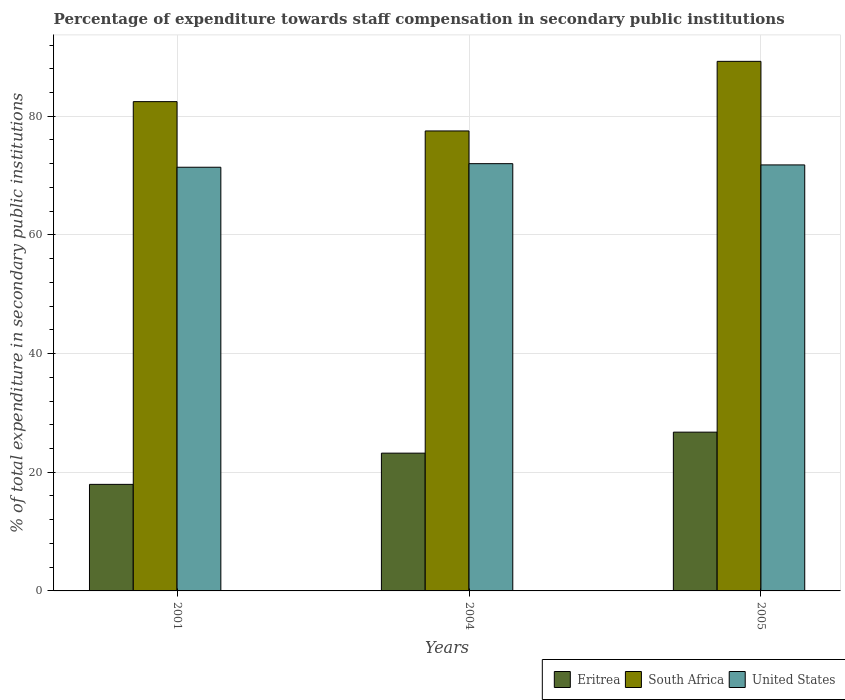How many different coloured bars are there?
Your response must be concise. 3. How many groups of bars are there?
Provide a succinct answer. 3. Are the number of bars per tick equal to the number of legend labels?
Your answer should be very brief. Yes. How many bars are there on the 1st tick from the left?
Provide a short and direct response. 3. How many bars are there on the 1st tick from the right?
Make the answer very short. 3. What is the percentage of expenditure towards staff compensation in Eritrea in 2005?
Your answer should be compact. 26.76. Across all years, what is the maximum percentage of expenditure towards staff compensation in United States?
Give a very brief answer. 72.01. Across all years, what is the minimum percentage of expenditure towards staff compensation in Eritrea?
Provide a succinct answer. 17.96. In which year was the percentage of expenditure towards staff compensation in United States maximum?
Offer a very short reply. 2004. What is the total percentage of expenditure towards staff compensation in South Africa in the graph?
Your response must be concise. 249.22. What is the difference between the percentage of expenditure towards staff compensation in United States in 2001 and that in 2005?
Your answer should be compact. -0.39. What is the difference between the percentage of expenditure towards staff compensation in Eritrea in 2005 and the percentage of expenditure towards staff compensation in United States in 2001?
Your answer should be compact. -44.65. What is the average percentage of expenditure towards staff compensation in Eritrea per year?
Offer a terse response. 22.64. In the year 2001, what is the difference between the percentage of expenditure towards staff compensation in Eritrea and percentage of expenditure towards staff compensation in United States?
Your answer should be compact. -53.44. What is the ratio of the percentage of expenditure towards staff compensation in South Africa in 2004 to that in 2005?
Offer a very short reply. 0.87. Is the difference between the percentage of expenditure towards staff compensation in Eritrea in 2004 and 2005 greater than the difference between the percentage of expenditure towards staff compensation in United States in 2004 and 2005?
Provide a succinct answer. No. What is the difference between the highest and the second highest percentage of expenditure towards staff compensation in South Africa?
Your answer should be very brief. 6.79. What is the difference between the highest and the lowest percentage of expenditure towards staff compensation in United States?
Your answer should be very brief. 0.6. Is the sum of the percentage of expenditure towards staff compensation in Eritrea in 2001 and 2004 greater than the maximum percentage of expenditure towards staff compensation in United States across all years?
Offer a terse response. No. What does the 1st bar from the left in 2001 represents?
Provide a succinct answer. Eritrea. What does the 3rd bar from the right in 2004 represents?
Your answer should be compact. Eritrea. How many bars are there?
Provide a succinct answer. 9. Are all the bars in the graph horizontal?
Your answer should be compact. No. What is the difference between two consecutive major ticks on the Y-axis?
Provide a succinct answer. 20. Are the values on the major ticks of Y-axis written in scientific E-notation?
Keep it short and to the point. No. Does the graph contain any zero values?
Make the answer very short. No. Does the graph contain grids?
Offer a terse response. Yes. Where does the legend appear in the graph?
Make the answer very short. Bottom right. How are the legend labels stacked?
Your response must be concise. Horizontal. What is the title of the graph?
Offer a terse response. Percentage of expenditure towards staff compensation in secondary public institutions. Does "Singapore" appear as one of the legend labels in the graph?
Your answer should be compact. No. What is the label or title of the X-axis?
Provide a succinct answer. Years. What is the label or title of the Y-axis?
Offer a very short reply. % of total expenditure in secondary public institutions. What is the % of total expenditure in secondary public institutions in Eritrea in 2001?
Offer a very short reply. 17.96. What is the % of total expenditure in secondary public institutions of South Africa in 2001?
Ensure brevity in your answer.  82.46. What is the % of total expenditure in secondary public institutions of United States in 2001?
Your answer should be compact. 71.4. What is the % of total expenditure in secondary public institutions in Eritrea in 2004?
Your response must be concise. 23.22. What is the % of total expenditure in secondary public institutions in South Africa in 2004?
Your answer should be very brief. 77.52. What is the % of total expenditure in secondary public institutions in United States in 2004?
Ensure brevity in your answer.  72.01. What is the % of total expenditure in secondary public institutions of Eritrea in 2005?
Provide a short and direct response. 26.76. What is the % of total expenditure in secondary public institutions in South Africa in 2005?
Your answer should be compact. 89.25. What is the % of total expenditure in secondary public institutions of United States in 2005?
Provide a succinct answer. 71.79. Across all years, what is the maximum % of total expenditure in secondary public institutions in Eritrea?
Your answer should be very brief. 26.76. Across all years, what is the maximum % of total expenditure in secondary public institutions in South Africa?
Provide a succinct answer. 89.25. Across all years, what is the maximum % of total expenditure in secondary public institutions in United States?
Keep it short and to the point. 72.01. Across all years, what is the minimum % of total expenditure in secondary public institutions in Eritrea?
Your response must be concise. 17.96. Across all years, what is the minimum % of total expenditure in secondary public institutions in South Africa?
Keep it short and to the point. 77.52. Across all years, what is the minimum % of total expenditure in secondary public institutions of United States?
Your answer should be compact. 71.4. What is the total % of total expenditure in secondary public institutions in Eritrea in the graph?
Provide a succinct answer. 67.93. What is the total % of total expenditure in secondary public institutions of South Africa in the graph?
Ensure brevity in your answer.  249.22. What is the total % of total expenditure in secondary public institutions in United States in the graph?
Give a very brief answer. 215.2. What is the difference between the % of total expenditure in secondary public institutions in Eritrea in 2001 and that in 2004?
Give a very brief answer. -5.26. What is the difference between the % of total expenditure in secondary public institutions in South Africa in 2001 and that in 2004?
Give a very brief answer. 4.94. What is the difference between the % of total expenditure in secondary public institutions of United States in 2001 and that in 2004?
Give a very brief answer. -0.6. What is the difference between the % of total expenditure in secondary public institutions in Eritrea in 2001 and that in 2005?
Give a very brief answer. -8.8. What is the difference between the % of total expenditure in secondary public institutions of South Africa in 2001 and that in 2005?
Provide a succinct answer. -6.79. What is the difference between the % of total expenditure in secondary public institutions in United States in 2001 and that in 2005?
Your answer should be very brief. -0.39. What is the difference between the % of total expenditure in secondary public institutions of Eritrea in 2004 and that in 2005?
Provide a succinct answer. -3.54. What is the difference between the % of total expenditure in secondary public institutions of South Africa in 2004 and that in 2005?
Your answer should be very brief. -11.73. What is the difference between the % of total expenditure in secondary public institutions in United States in 2004 and that in 2005?
Your answer should be very brief. 0.21. What is the difference between the % of total expenditure in secondary public institutions of Eritrea in 2001 and the % of total expenditure in secondary public institutions of South Africa in 2004?
Offer a terse response. -59.56. What is the difference between the % of total expenditure in secondary public institutions in Eritrea in 2001 and the % of total expenditure in secondary public institutions in United States in 2004?
Your answer should be compact. -54.05. What is the difference between the % of total expenditure in secondary public institutions in South Africa in 2001 and the % of total expenditure in secondary public institutions in United States in 2004?
Your answer should be very brief. 10.45. What is the difference between the % of total expenditure in secondary public institutions of Eritrea in 2001 and the % of total expenditure in secondary public institutions of South Africa in 2005?
Give a very brief answer. -71.29. What is the difference between the % of total expenditure in secondary public institutions in Eritrea in 2001 and the % of total expenditure in secondary public institutions in United States in 2005?
Your answer should be compact. -53.84. What is the difference between the % of total expenditure in secondary public institutions of South Africa in 2001 and the % of total expenditure in secondary public institutions of United States in 2005?
Give a very brief answer. 10.66. What is the difference between the % of total expenditure in secondary public institutions of Eritrea in 2004 and the % of total expenditure in secondary public institutions of South Africa in 2005?
Make the answer very short. -66.03. What is the difference between the % of total expenditure in secondary public institutions in Eritrea in 2004 and the % of total expenditure in secondary public institutions in United States in 2005?
Your answer should be compact. -48.58. What is the difference between the % of total expenditure in secondary public institutions in South Africa in 2004 and the % of total expenditure in secondary public institutions in United States in 2005?
Offer a very short reply. 5.72. What is the average % of total expenditure in secondary public institutions of Eritrea per year?
Your answer should be very brief. 22.64. What is the average % of total expenditure in secondary public institutions of South Africa per year?
Keep it short and to the point. 83.08. What is the average % of total expenditure in secondary public institutions of United States per year?
Offer a very short reply. 71.73. In the year 2001, what is the difference between the % of total expenditure in secondary public institutions in Eritrea and % of total expenditure in secondary public institutions in South Africa?
Your answer should be compact. -64.5. In the year 2001, what is the difference between the % of total expenditure in secondary public institutions of Eritrea and % of total expenditure in secondary public institutions of United States?
Provide a succinct answer. -53.44. In the year 2001, what is the difference between the % of total expenditure in secondary public institutions in South Africa and % of total expenditure in secondary public institutions in United States?
Your answer should be very brief. 11.06. In the year 2004, what is the difference between the % of total expenditure in secondary public institutions in Eritrea and % of total expenditure in secondary public institutions in South Africa?
Your response must be concise. -54.3. In the year 2004, what is the difference between the % of total expenditure in secondary public institutions in Eritrea and % of total expenditure in secondary public institutions in United States?
Keep it short and to the point. -48.79. In the year 2004, what is the difference between the % of total expenditure in secondary public institutions of South Africa and % of total expenditure in secondary public institutions of United States?
Keep it short and to the point. 5.51. In the year 2005, what is the difference between the % of total expenditure in secondary public institutions of Eritrea and % of total expenditure in secondary public institutions of South Africa?
Keep it short and to the point. -62.49. In the year 2005, what is the difference between the % of total expenditure in secondary public institutions of Eritrea and % of total expenditure in secondary public institutions of United States?
Keep it short and to the point. -45.04. In the year 2005, what is the difference between the % of total expenditure in secondary public institutions in South Africa and % of total expenditure in secondary public institutions in United States?
Your answer should be compact. 17.45. What is the ratio of the % of total expenditure in secondary public institutions in Eritrea in 2001 to that in 2004?
Offer a terse response. 0.77. What is the ratio of the % of total expenditure in secondary public institutions of South Africa in 2001 to that in 2004?
Offer a terse response. 1.06. What is the ratio of the % of total expenditure in secondary public institutions of Eritrea in 2001 to that in 2005?
Your answer should be very brief. 0.67. What is the ratio of the % of total expenditure in secondary public institutions in South Africa in 2001 to that in 2005?
Your answer should be compact. 0.92. What is the ratio of the % of total expenditure in secondary public institutions of Eritrea in 2004 to that in 2005?
Give a very brief answer. 0.87. What is the ratio of the % of total expenditure in secondary public institutions of South Africa in 2004 to that in 2005?
Offer a very short reply. 0.87. What is the difference between the highest and the second highest % of total expenditure in secondary public institutions in Eritrea?
Provide a short and direct response. 3.54. What is the difference between the highest and the second highest % of total expenditure in secondary public institutions in South Africa?
Offer a very short reply. 6.79. What is the difference between the highest and the second highest % of total expenditure in secondary public institutions of United States?
Keep it short and to the point. 0.21. What is the difference between the highest and the lowest % of total expenditure in secondary public institutions in Eritrea?
Your answer should be very brief. 8.8. What is the difference between the highest and the lowest % of total expenditure in secondary public institutions in South Africa?
Offer a terse response. 11.73. What is the difference between the highest and the lowest % of total expenditure in secondary public institutions in United States?
Give a very brief answer. 0.6. 